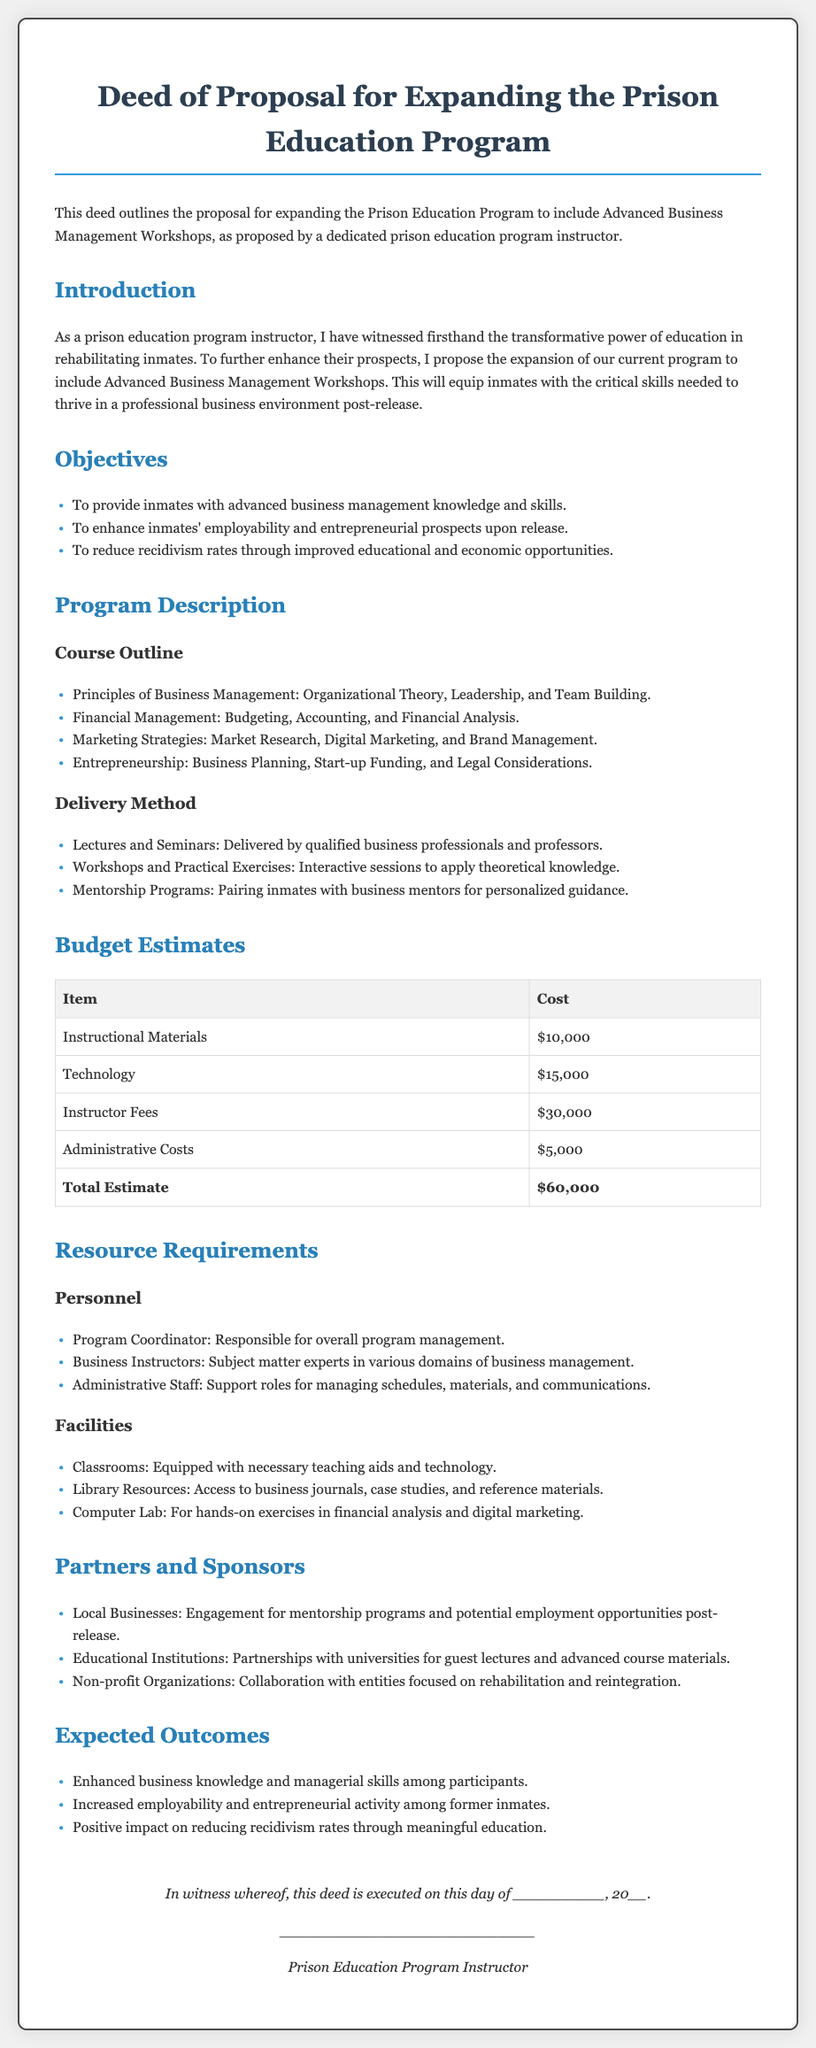What is the total estimated budget for the program? The total estimated budget is presented in the budget section of the document and sums all costs mentioned.
Answer: $60,000 Who is responsible for overall program management? The document states that the Program Coordinator is responsible for overall program management, highlighting their role in the resource requirements section.
Answer: Program Coordinator What is one of the key objectives of the program? The objectives listed in the document highlight various goals, such as improving employability and economic opportunities for inmates.
Answer: To enhance inmates' employability and entrepreneurial prospects upon release How many categories are outlined in the course outline section? The course outline details four distinct categories of business management skills and knowledge being imparted to the inmates.
Answer: Four Which type of professionals will deliver the lectures and seminars? The delivery method section specifies that qualified business professionals and professors will conduct the lectures and seminars, emphasizing the expertise involved.
Answer: Qualified business professionals and professors What is included in the facilities requirement for the program? The facilities requirement outlines what is needed for the program, including classrooms, library resources, and a computer lab essential for hands-on learning.
Answer: Classrooms, Library Resources, Computer Lab What are the expected outcomes of the program? The document lists expected outcomes, emphasizing enhancements in knowledge, employability, and reduction in recidivism rates that the program aims to achieve.
Answer: Enhanced business knowledge and managerial skills among participants Which types of organizations are targeted for partnerships? The partnerships section mentions several types of organizations, such as local businesses and educational institutions, as potential partners for the program.
Answer: Local Businesses, Educational Institutions, Non-profit Organizations 